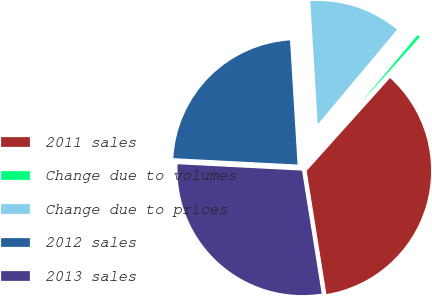Convert chart. <chart><loc_0><loc_0><loc_500><loc_500><pie_chart><fcel>2011 sales<fcel>Change due to volumes<fcel>Change due to prices<fcel>2012 sales<fcel>2013 sales<nl><fcel>35.83%<fcel>0.55%<fcel>12.06%<fcel>23.22%<fcel>28.34%<nl></chart> 